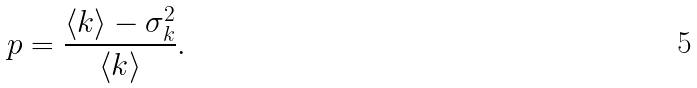<formula> <loc_0><loc_0><loc_500><loc_500>p = \frac { \langle k \rangle - \sigma _ { k } ^ { 2 } } { \langle k \rangle } .</formula> 